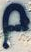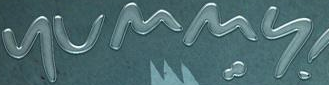Read the text from these images in sequence, separated by a semicolon. p; yummy 